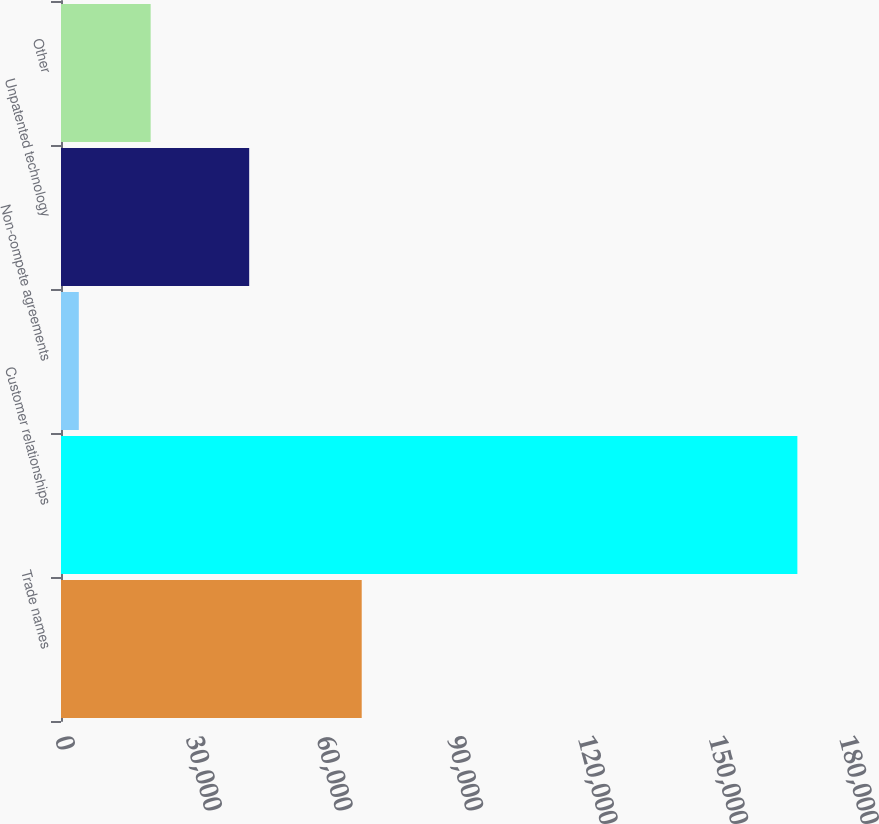Convert chart. <chart><loc_0><loc_0><loc_500><loc_500><bar_chart><fcel>Trade names<fcel>Customer relationships<fcel>Non-compete agreements<fcel>Unpatented technology<fcel>Other<nl><fcel>69043<fcel>169065<fcel>4087<fcel>43206<fcel>20584.8<nl></chart> 